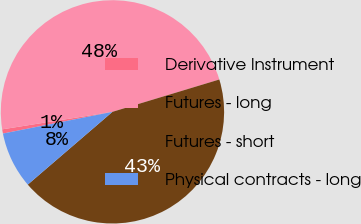Convert chart to OTSL. <chart><loc_0><loc_0><loc_500><loc_500><pie_chart><fcel>Derivative Instrument<fcel>Futures - long<fcel>Futures - short<fcel>Physical contracts - long<nl><fcel>0.61%<fcel>47.83%<fcel>43.38%<fcel>8.18%<nl></chart> 